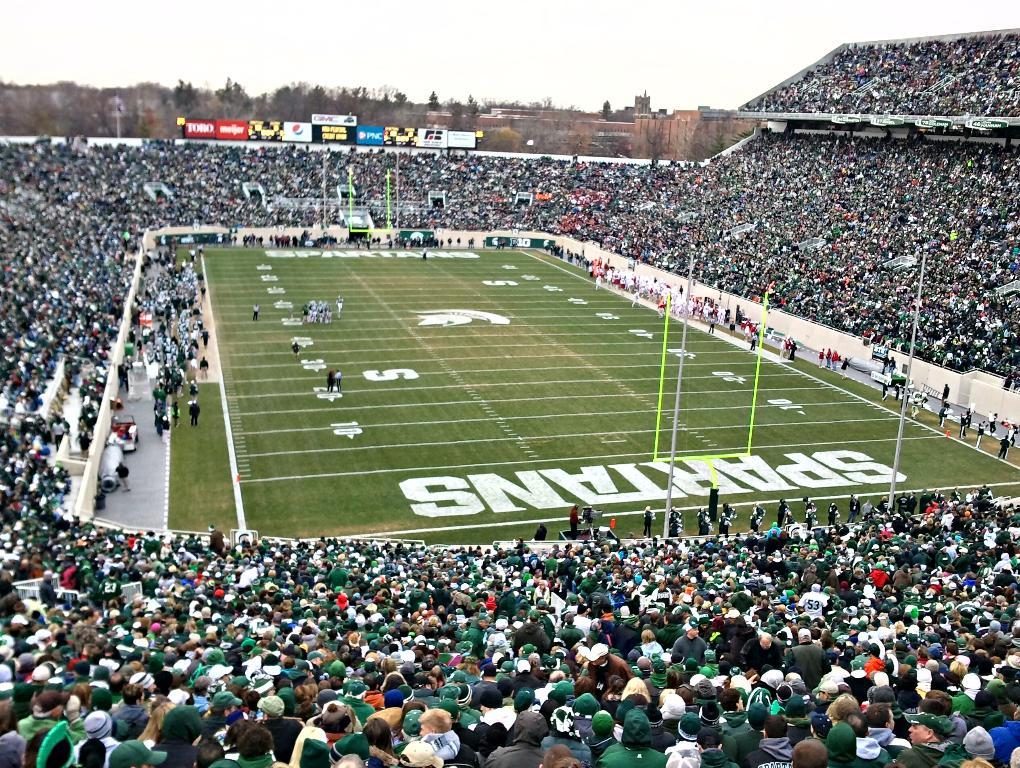What's the team mascot here?
Keep it short and to the point. Spartans. What is the bank on the blue sponsored banner?
Your response must be concise. Pnc. 